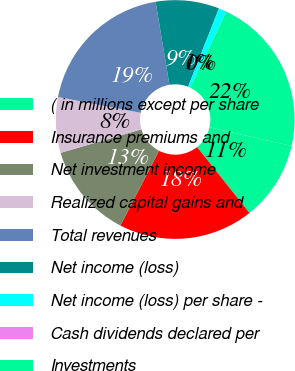<chart> <loc_0><loc_0><loc_500><loc_500><pie_chart><fcel>( in millions except per share<fcel>Insurance premiums and<fcel>Net investment income<fcel>Realized capital gains and<fcel>Total revenues<fcel>Net income (loss)<fcel>Net income (loss) per share -<fcel>Cash dividends declared per<fcel>Investments<nl><fcel>10.75%<fcel>18.28%<fcel>12.9%<fcel>7.53%<fcel>19.35%<fcel>8.6%<fcel>1.08%<fcel>0.0%<fcel>21.51%<nl></chart> 